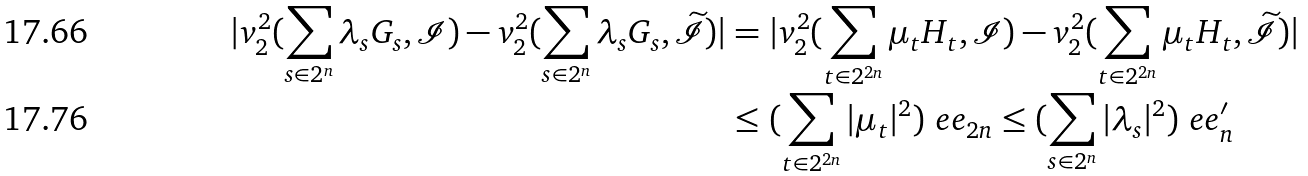Convert formula to latex. <formula><loc_0><loc_0><loc_500><loc_500>| v _ { 2 } ^ { 2 } ( \sum _ { s \in 2 ^ { n } } \lambda _ { s } G _ { s } , \mathcal { I } ) - v _ { 2 } ^ { 2 } ( \sum _ { s \in 2 ^ { n } } \lambda _ { s } G _ { s } , \widetilde { \mathcal { I } } ) | & = | v _ { 2 } ^ { 2 } ( \sum _ { t \in 2 ^ { 2 n } } \mu _ { t } H _ { t } , \mathcal { I } ) - v _ { 2 } ^ { 2 } ( \sum _ { t \in 2 ^ { 2 n } } \mu _ { t } H _ { t } , \widetilde { \mathcal { I } } ) | \\ & \leq ( \sum _ { t \in 2 ^ { 2 n } } | \mu _ { t } | ^ { 2 } ) \ e e _ { 2 n } \leq ( \sum _ { s \in 2 ^ { n } } | \lambda _ { s } | ^ { 2 } ) \ e e _ { n } ^ { \prime }</formula> 